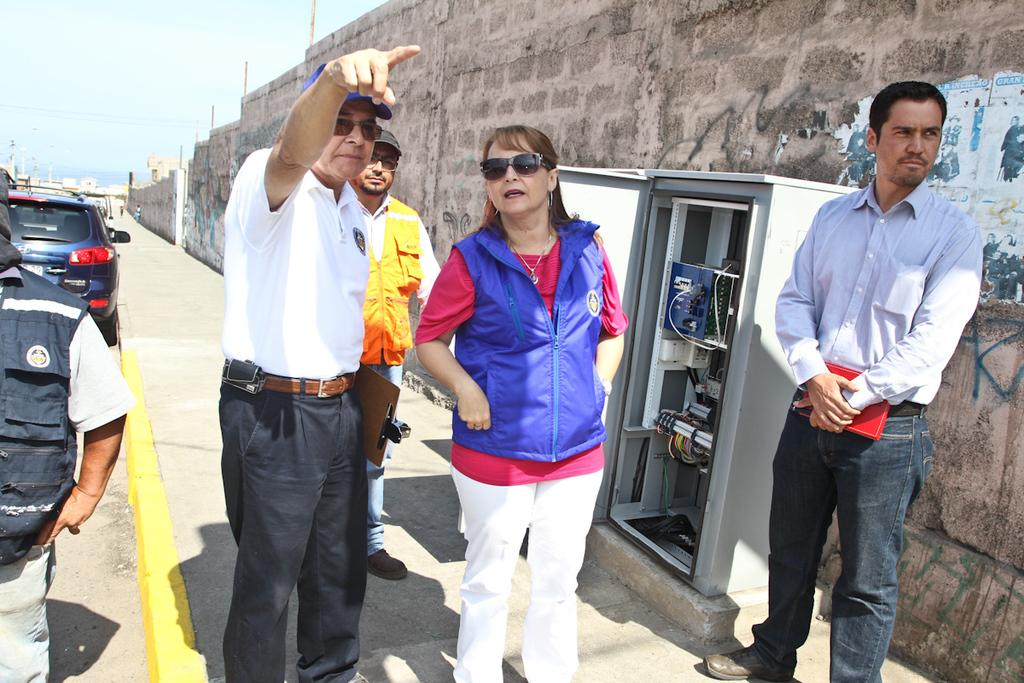What can be seen in the image? There are people standing in the image. What is located on the right side of the image? There is an electric cabinet and a wall on the right side of the image. What is visible in the background of the image? There is a car, poles, and the sky visible in the background of the image. What type of texture can be seen on the yam in the image? There is no yam present in the image, so it is not possible to determine its texture. What is the fork used for in the image? There is no fork present in the image, so it cannot be used for anything. 